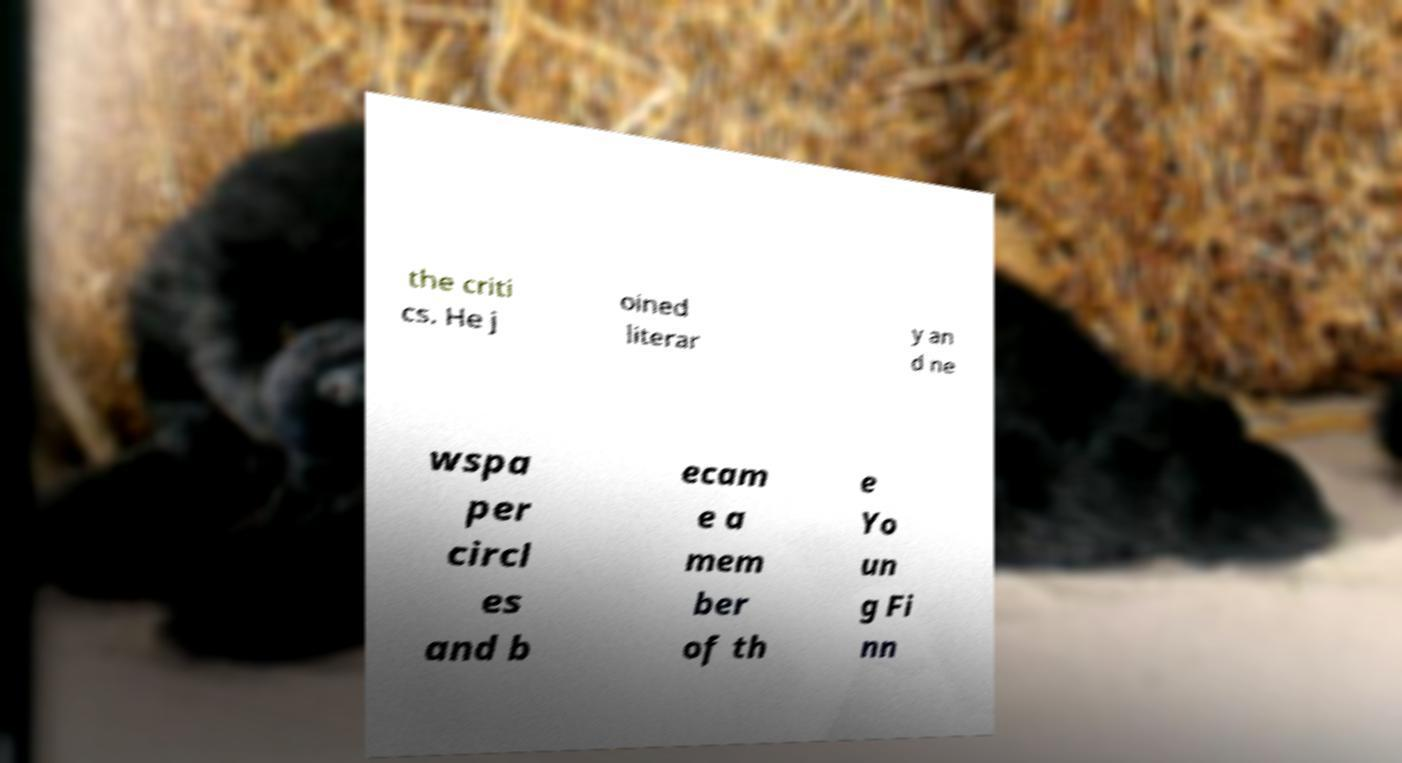For documentation purposes, I need the text within this image transcribed. Could you provide that? the criti cs. He j oined literar y an d ne wspa per circl es and b ecam e a mem ber of th e Yo un g Fi nn 